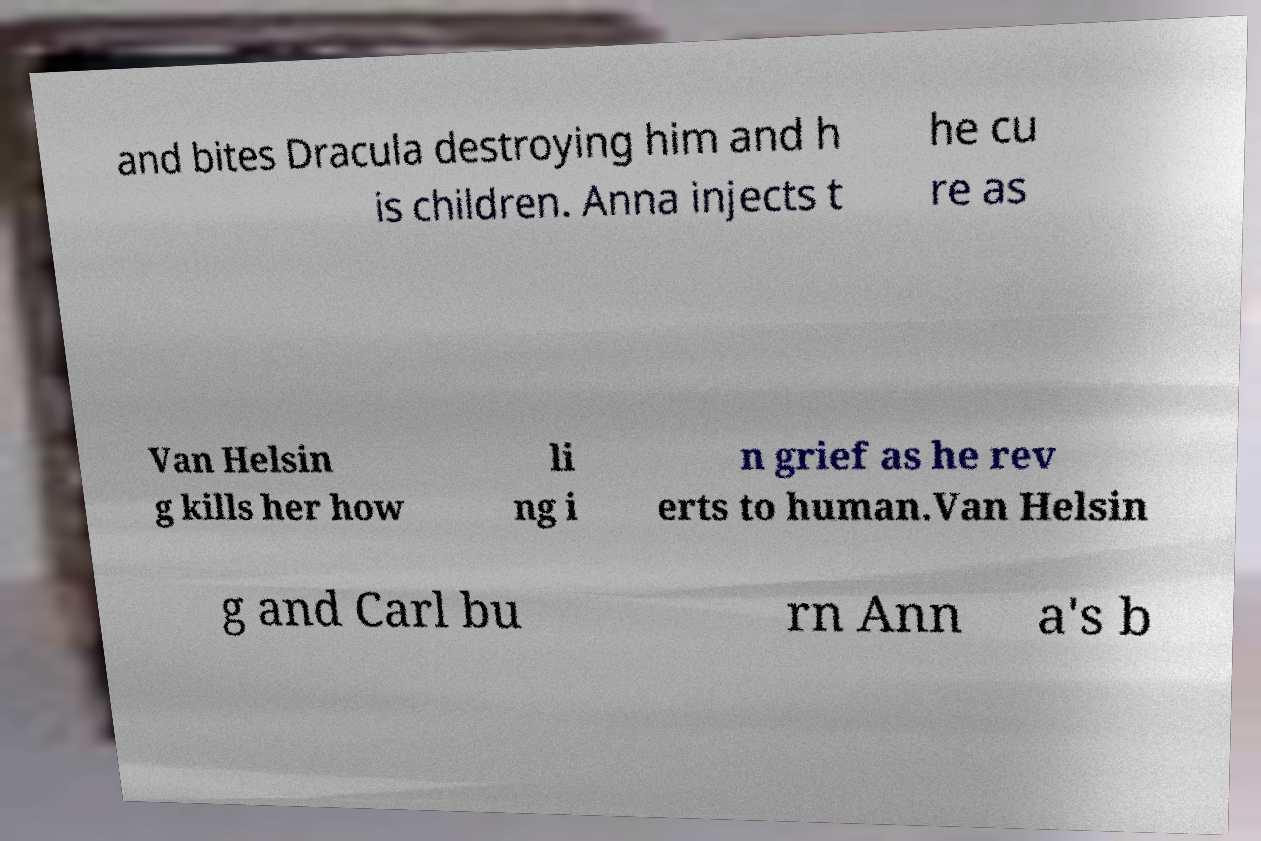Please identify and transcribe the text found in this image. and bites Dracula destroying him and h is children. Anna injects t he cu re as Van Helsin g kills her how li ng i n grief as he rev erts to human.Van Helsin g and Carl bu rn Ann a's b 